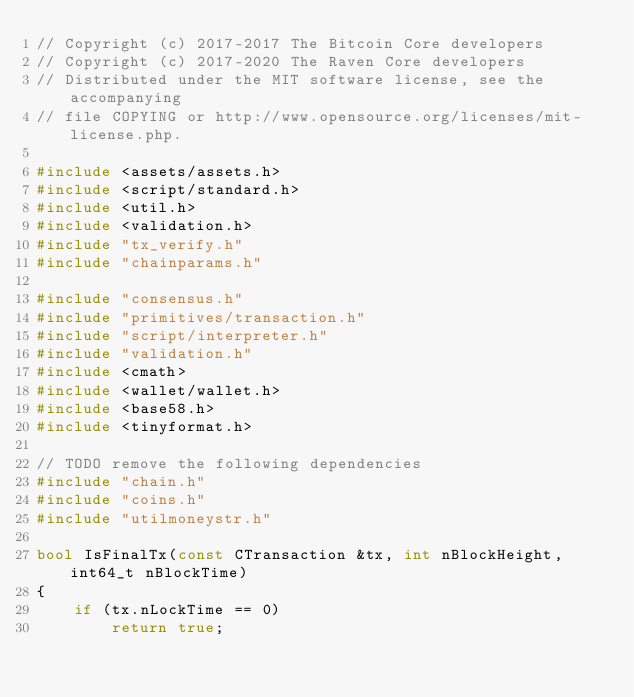<code> <loc_0><loc_0><loc_500><loc_500><_C++_>// Copyright (c) 2017-2017 The Bitcoin Core developers
// Copyright (c) 2017-2020 The Raven Core developers
// Distributed under the MIT software license, see the accompanying
// file COPYING or http://www.opensource.org/licenses/mit-license.php.

#include <assets/assets.h>
#include <script/standard.h>
#include <util.h>
#include <validation.h>
#include "tx_verify.h"
#include "chainparams.h"

#include "consensus.h"
#include "primitives/transaction.h"
#include "script/interpreter.h"
#include "validation.h"
#include <cmath>
#include <wallet/wallet.h>
#include <base58.h>
#include <tinyformat.h>

// TODO remove the following dependencies
#include "chain.h"
#include "coins.h"
#include "utilmoneystr.h"

bool IsFinalTx(const CTransaction &tx, int nBlockHeight, int64_t nBlockTime)
{
    if (tx.nLockTime == 0)
        return true;</code> 